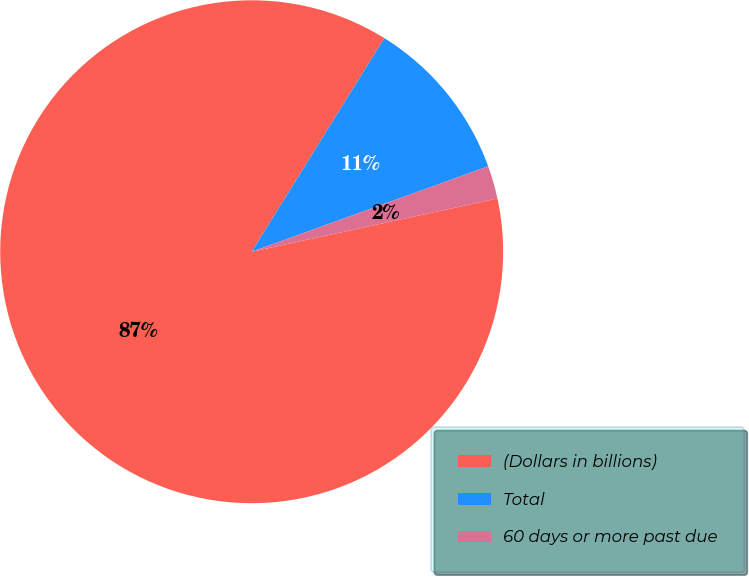Convert chart. <chart><loc_0><loc_0><loc_500><loc_500><pie_chart><fcel>(Dollars in billions)<fcel>Total<fcel>60 days or more past due<nl><fcel>87.24%<fcel>10.64%<fcel>2.12%<nl></chart> 